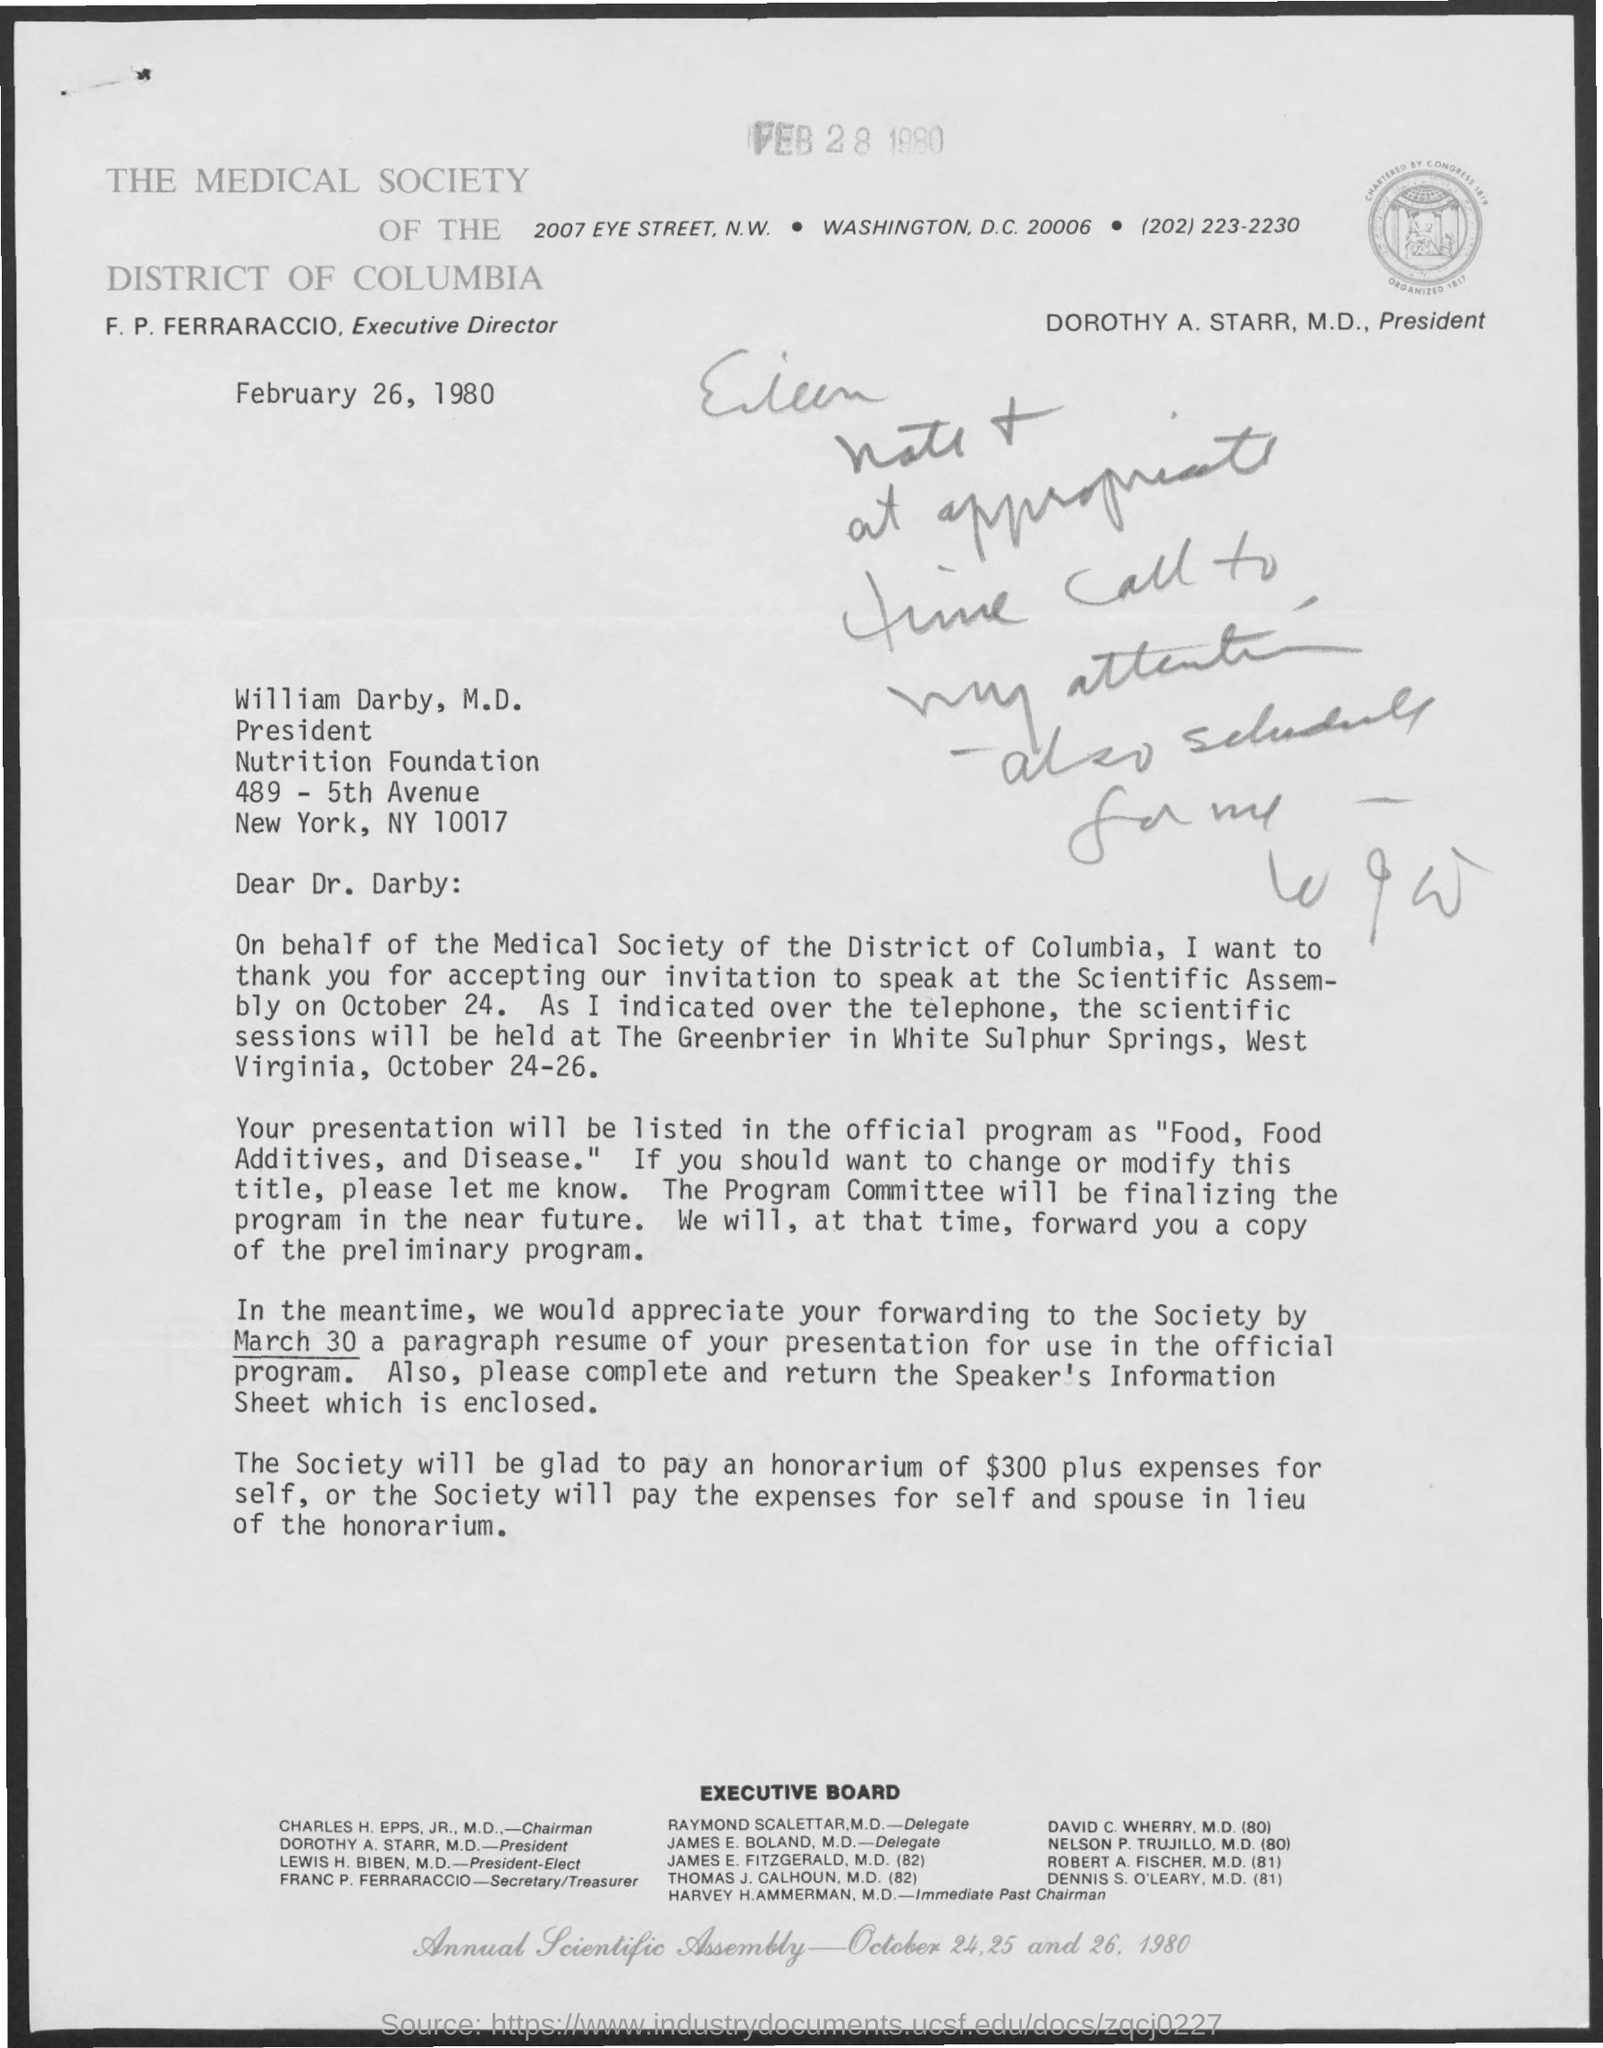Point out several critical features in this image. The document is dated February 26, 1980. A paragraph resume for the presentation should be forwarded by March 30 for inclusion in the official program. The honorarium for the event is $300, plus expenses for the self-represented party. The Executive Director of THE MEDICAL SOCIETY OF THE DISTRICT OF COLUMBIA is F. P. Ferraraccio. 